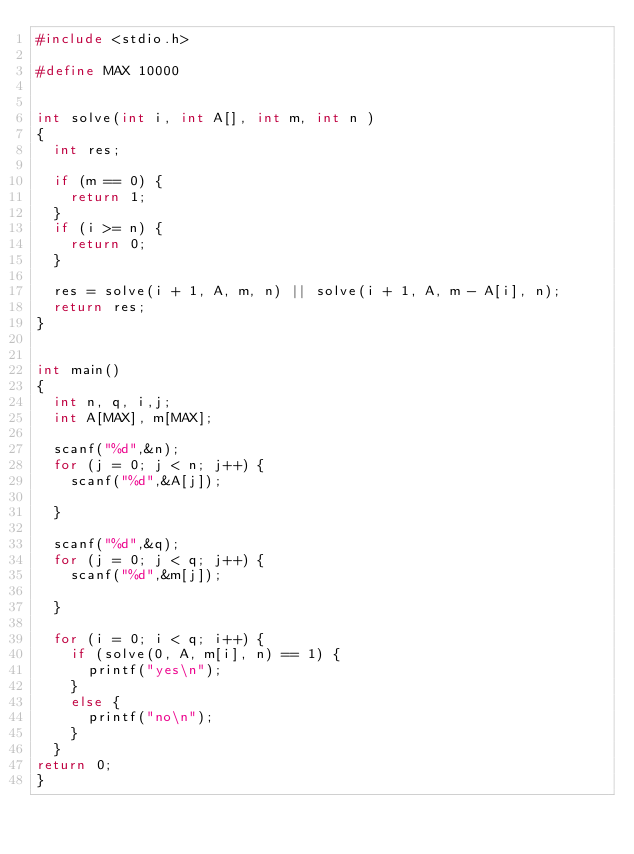Convert code to text. <code><loc_0><loc_0><loc_500><loc_500><_C_>#include <stdio.h>

#define MAX 10000


int solve(int i, int A[], int m, int n )
{
	int res;
	
	if (m == 0) {
		return 1;
	}
	if (i >= n) {
		return 0;
	}
	
	res = solve(i + 1, A, m, n) || solve(i + 1, A, m - A[i], n);
	return res;
}
		

int main()
{
	int n, q, i,j;
	int A[MAX], m[MAX];
	
	scanf("%d",&n);
	for (j = 0; j < n; j++) {
		scanf("%d",&A[j]);
		
	}
	
	scanf("%d",&q);
	for (j = 0; j < q; j++) {
		scanf("%d",&m[j]);
		
	}
	
	for (i = 0; i < q; i++) {
		if (solve(0, A, m[i], n) == 1) {
			printf("yes\n");
		}
		else {
			printf("no\n");
		}
	}
return 0;
}
</code> 